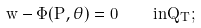Convert formula to latex. <formula><loc_0><loc_0><loc_500><loc_500>w - \Phi ( P , \theta ) = 0 \quad i n Q _ { T } ;</formula> 